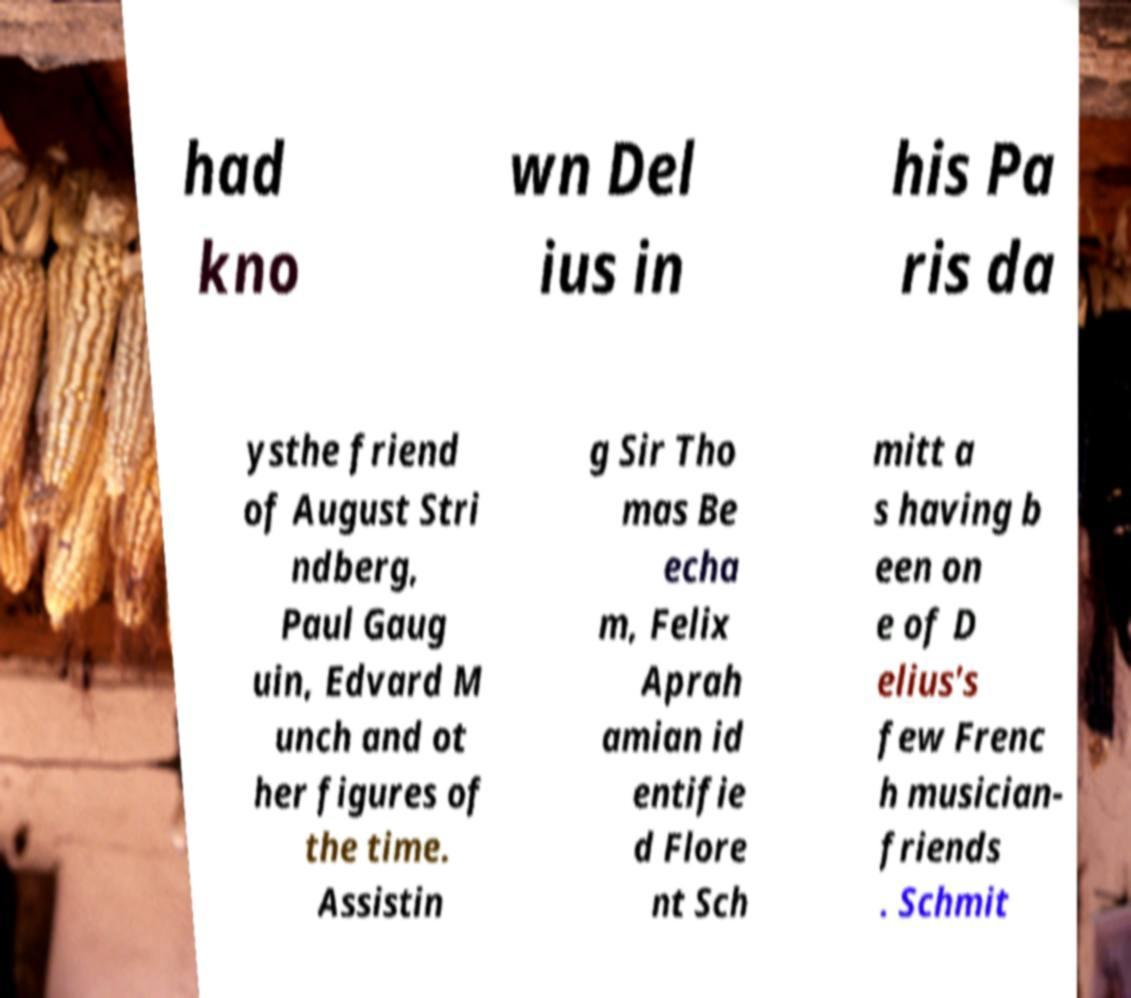I need the written content from this picture converted into text. Can you do that? had kno wn Del ius in his Pa ris da ysthe friend of August Stri ndberg, Paul Gaug uin, Edvard M unch and ot her figures of the time. Assistin g Sir Tho mas Be echa m, Felix Aprah amian id entifie d Flore nt Sch mitt a s having b een on e of D elius's few Frenc h musician- friends . Schmit 